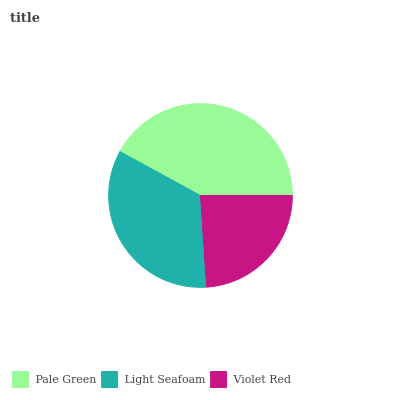Is Violet Red the minimum?
Answer yes or no. Yes. Is Pale Green the maximum?
Answer yes or no. Yes. Is Light Seafoam the minimum?
Answer yes or no. No. Is Light Seafoam the maximum?
Answer yes or no. No. Is Pale Green greater than Light Seafoam?
Answer yes or no. Yes. Is Light Seafoam less than Pale Green?
Answer yes or no. Yes. Is Light Seafoam greater than Pale Green?
Answer yes or no. No. Is Pale Green less than Light Seafoam?
Answer yes or no. No. Is Light Seafoam the high median?
Answer yes or no. Yes. Is Light Seafoam the low median?
Answer yes or no. Yes. Is Violet Red the high median?
Answer yes or no. No. Is Violet Red the low median?
Answer yes or no. No. 